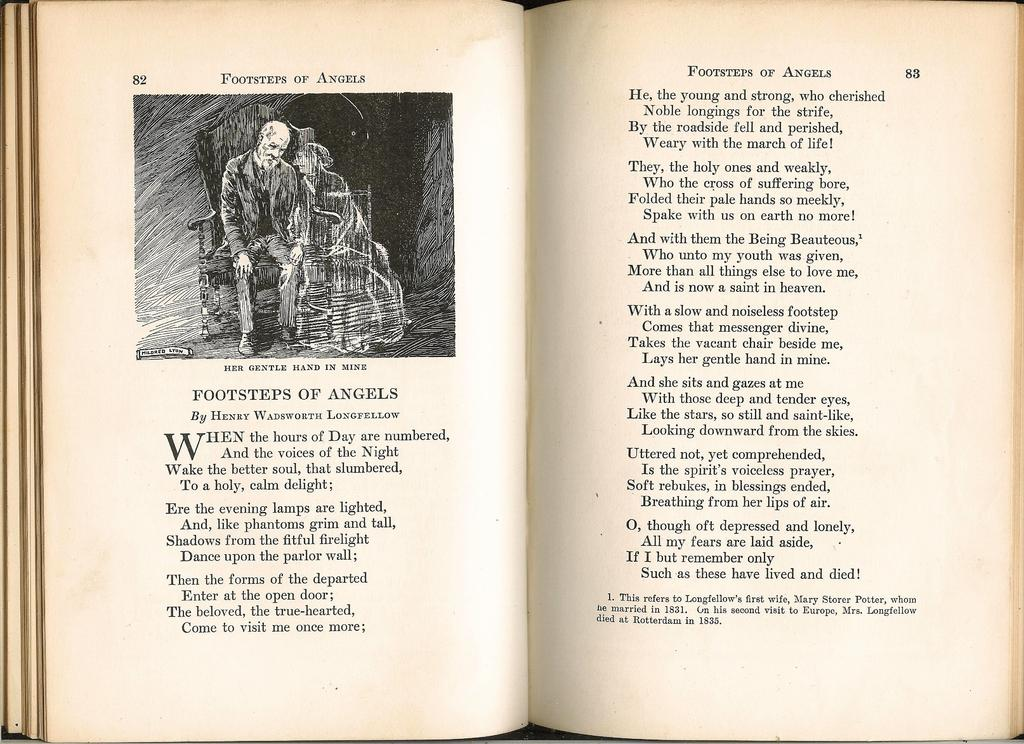<image>
Offer a succinct explanation of the picture presented. A poem using rhymes every two sentences, on the 82nd and 83rd page of a book. 